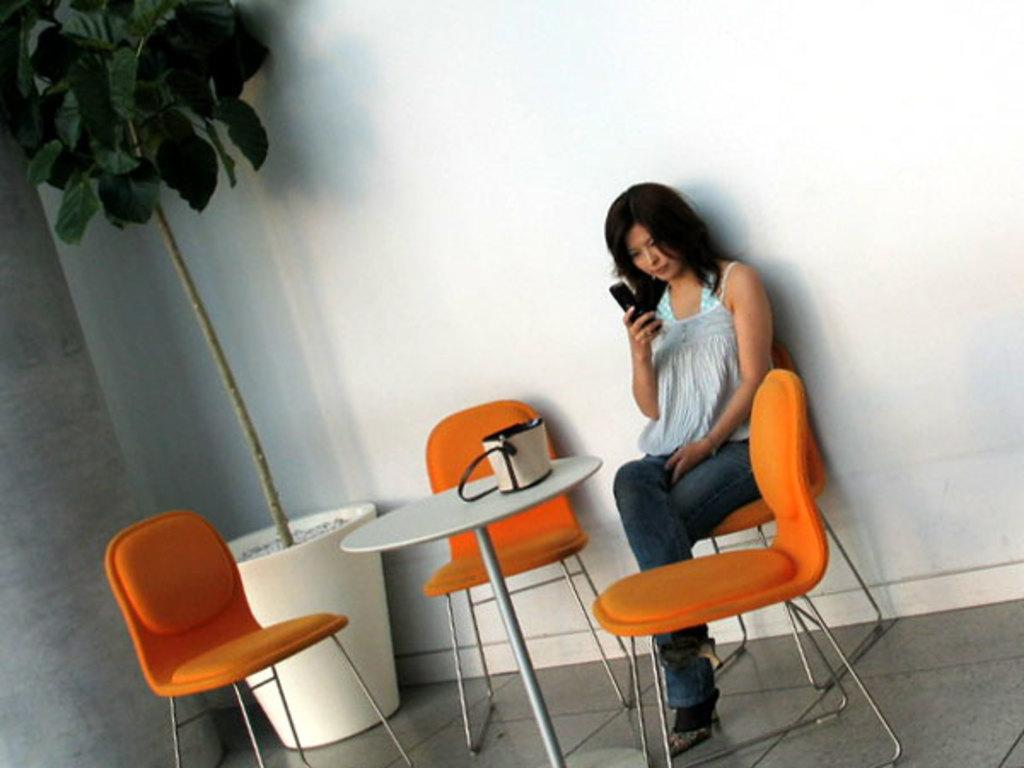Who is present in the image? There is a woman in the image. What is the woman doing in the image? The woman is sitting on a chair. What object is in front of the woman? There is a table in front of the woman. What item can be seen on the table? There is a handbag on the table. What can be seen in the corner of the image? There is a tree in the left side corner of the image. What type of glue is being used to attach the powder to the base in the image? There is no powder, base, or glue present in the image. 